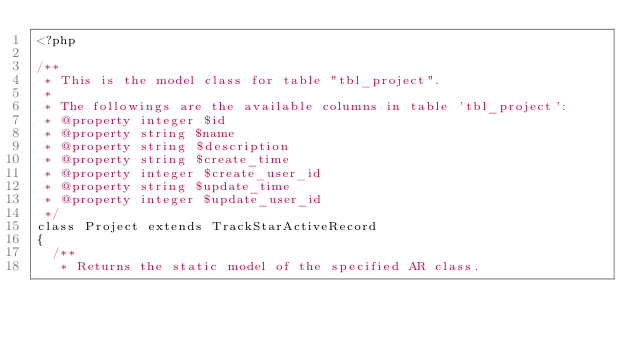Convert code to text. <code><loc_0><loc_0><loc_500><loc_500><_PHP_><?php

/**
 * This is the model class for table "tbl_project".
 *
 * The followings are the available columns in table 'tbl_project':
 * @property integer $id
 * @property string $name
 * @property string $description
 * @property string $create_time
 * @property integer $create_user_id
 * @property string $update_time
 * @property integer $update_user_id
 */
class Project extends TrackStarActiveRecord
{
	/**
	 * Returns the static model of the specified AR class.</code> 